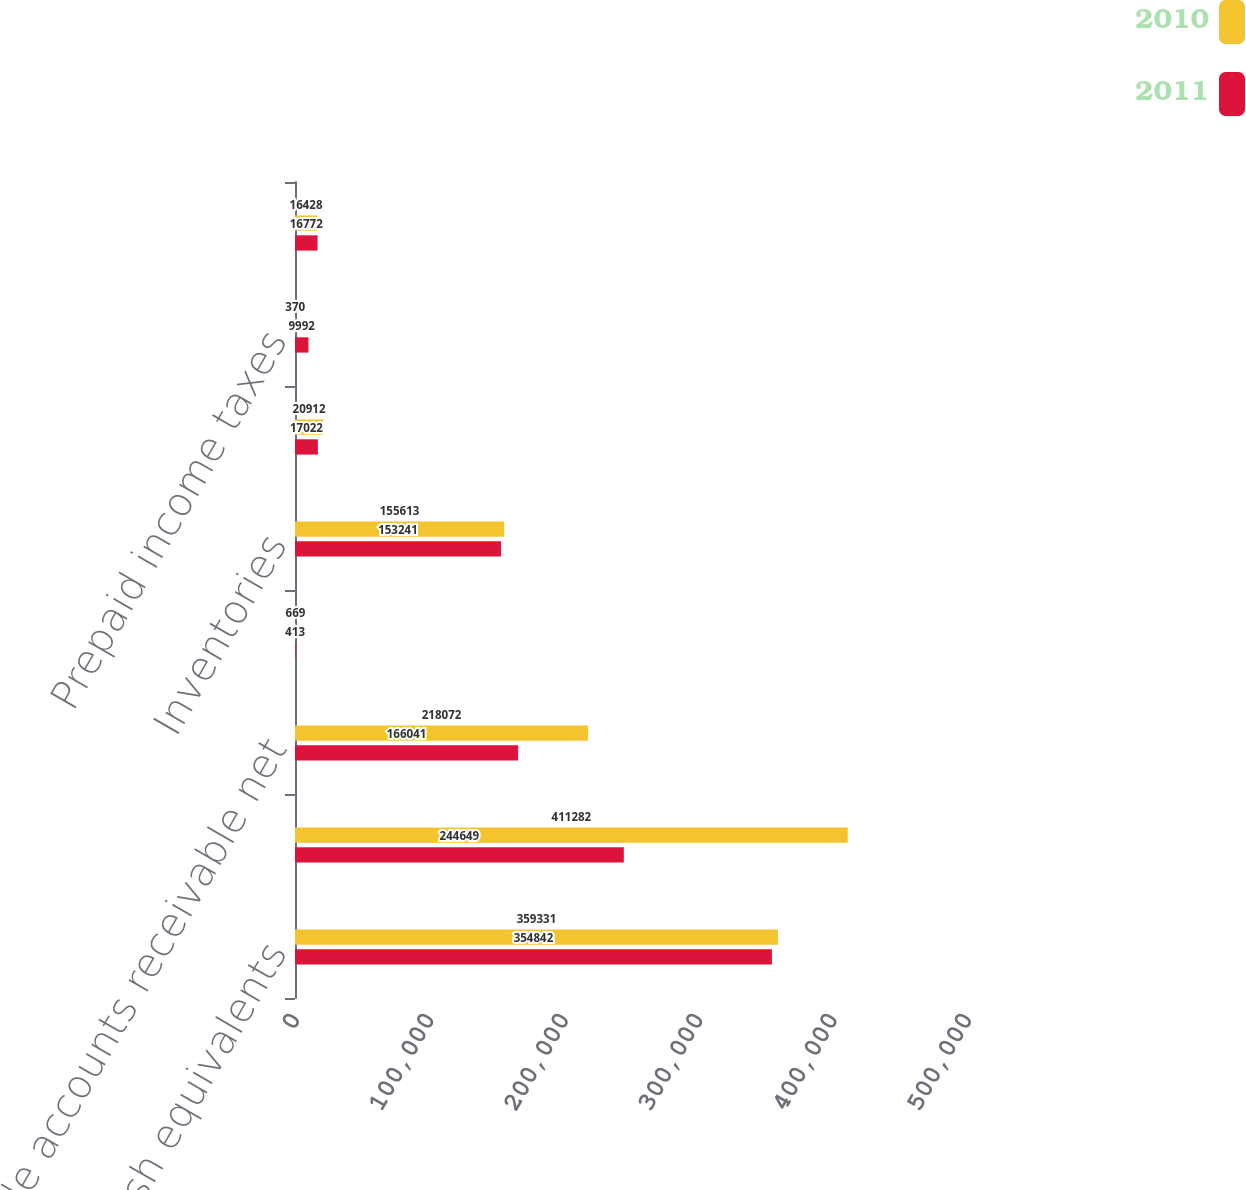Convert chart. <chart><loc_0><loc_0><loc_500><loc_500><stacked_bar_chart><ecel><fcel>Cash and cash equivalents<fcel>Short-term investments<fcel>Trade accounts receivable net<fcel>Distributor receivables<fcel>Inventories<fcel>Prepaid expenses and other<fcel>Prepaid income taxes<fcel>Deferred income taxes<nl><fcel>2010<fcel>359331<fcel>411282<fcel>218072<fcel>669<fcel>155613<fcel>20912<fcel>370<fcel>16428<nl><fcel>2011<fcel>354842<fcel>244649<fcel>166041<fcel>413<fcel>153241<fcel>17022<fcel>9992<fcel>16772<nl></chart> 